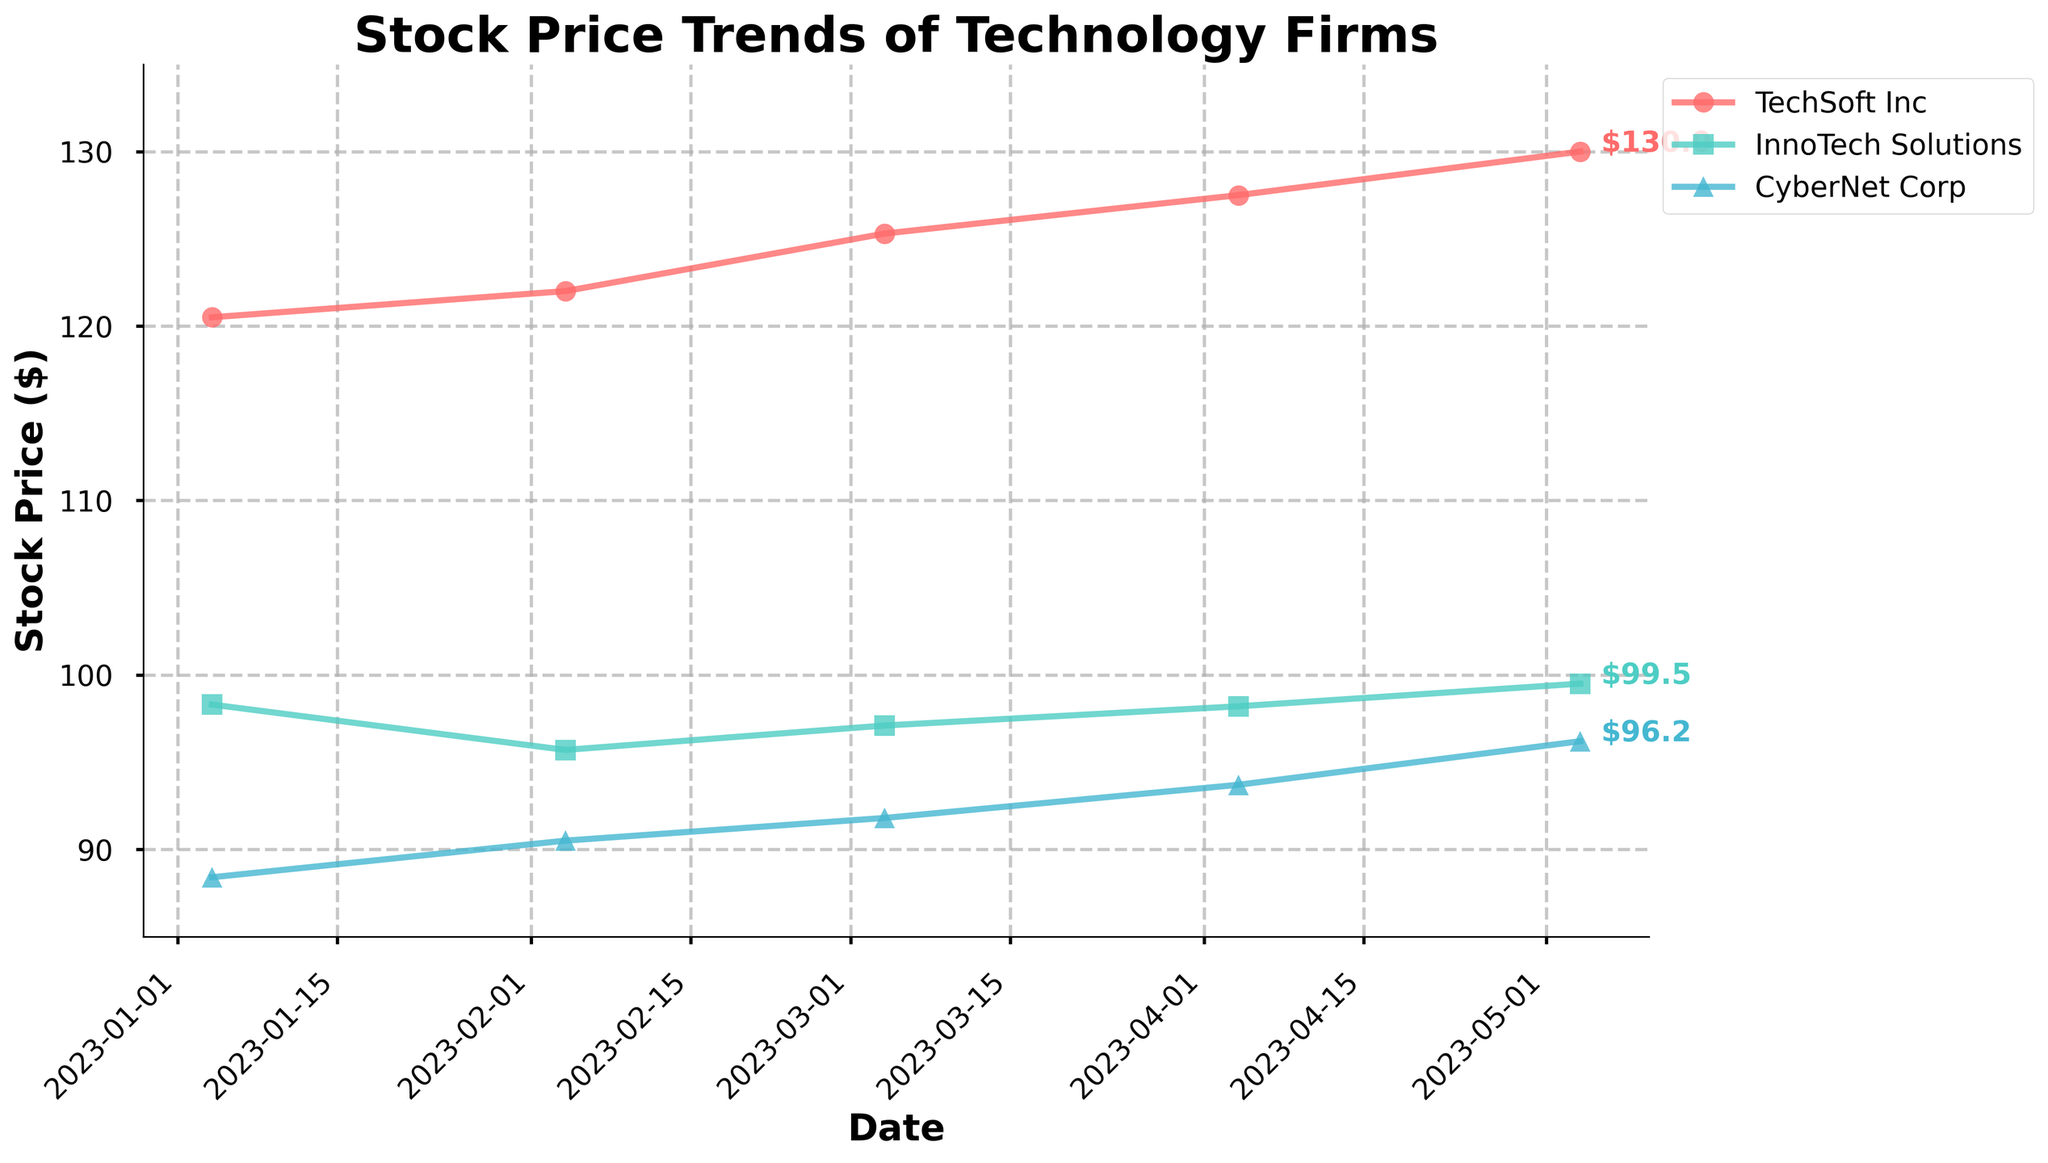What is the title of the plot? The title of the plot is shown at the top and usually provides a summary of what the plot represents. In this plot, it is "Stock Price Trends of Technology Firms".
Answer: Stock Price Trends of Technology Firms How many companies are represented in the plot? To find out how many companies are represented, look at the legend usually placed beside the plot. There are three distinct labels, representing three companies.
Answer: 3 Which company has the highest stock price in May 2023? To determine which company has the highest stock price in May 2023, check the stock prices on the chart for each company in that month. TechSoft Inc is indicated to have the highest stock price.
Answer: TechSoft Inc What is the range of stock prices shown on the y-axis? The range of stock prices can be found by looking at the y-axis, which starts at 85 and goes up to 135 dollars.
Answer: 85 to 135 How has TechSoft Inc's stock price changed from January to May 2023? Track the line representing TechSoft Inc. From January to May 2023, the stock price moved from 120.5 in January to 130.0 in May.
Answer: Increased by 9.5 Between which months did InnoTech Solutions experience the largest increase in stock price? Observe the shape of the trend line for InnoTech Solutions. The largest increase is seen between April and May 2023.
Answer: April to May 2023 Compare the stock prices of CyberNet Corp and InnoTech Solutions in January 2023. Look at the starting points of both lines in January 2023. CyberNet Corp had a stock price of 88.4, while InnoTech Solutions had a stock price of 98.3.
Answer: InnoTech Solutions had a higher stock price What trend is shown by the attrition rates of companies using Autocratic leadership? Autocratic leadership is associated with InnoTech Solutions. Its trend line indicates an increasing attrition rate from January (0.07) to May (0.12).
Answer: Increasing How does CyberNet Corp's stock price in May 2023 compare to January 2023? Examine the starting and ending points for CyberNet Corp. The stock price increased from 88.4 in January to 96.2 in May.
Answer: Increased by 7.8 